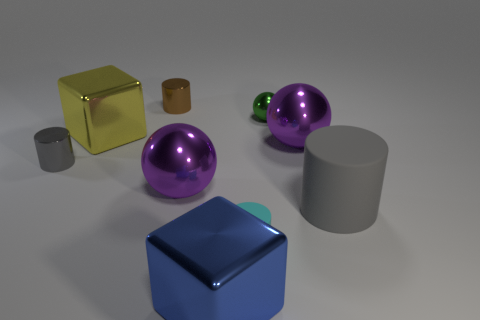Subtract all purple shiny balls. How many balls are left? 1 Subtract all blue cylinders. How many purple balls are left? 2 Subtract all green spheres. How many spheres are left? 2 Subtract 1 cylinders. How many cylinders are left? 3 Subtract 0 gray balls. How many objects are left? 9 Subtract all spheres. How many objects are left? 6 Subtract all blue blocks. Subtract all brown cylinders. How many blocks are left? 1 Subtract all tiny red metallic things. Subtract all large gray cylinders. How many objects are left? 8 Add 3 brown cylinders. How many brown cylinders are left? 4 Add 9 large cylinders. How many large cylinders exist? 10 